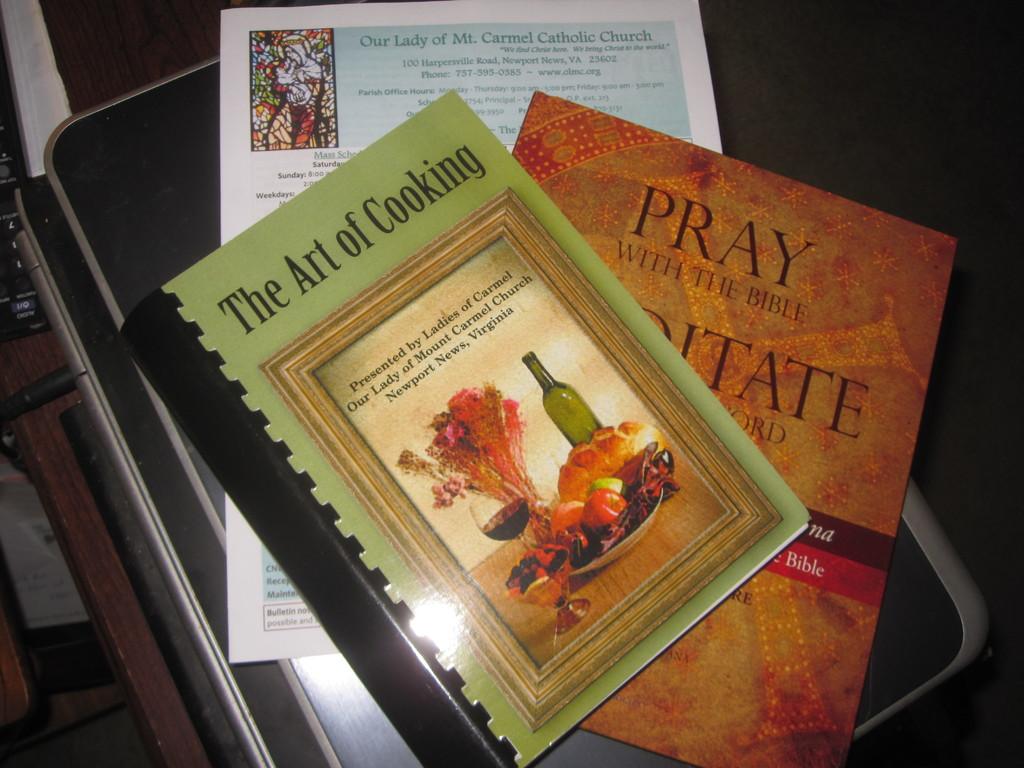What is the top word on the second book in this pile?
Your answer should be very brief. Pray. 